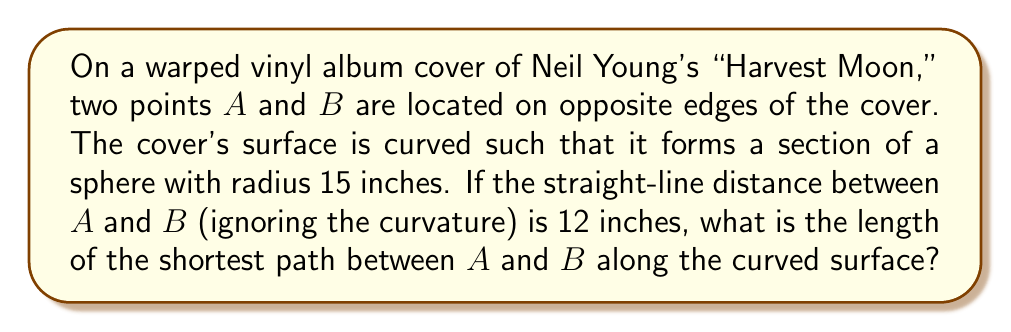Solve this math problem. To solve this problem, we need to use concepts from spherical geometry:

1) First, we need to find the central angle $\theta$ between the two points. We can do this using the formula for the chord length of a circle:

   $$ d = 2R \sin(\frac{\theta}{2}) $$

   Where $d$ is the straight-line distance, $R$ is the radius of the sphere, and $\theta$ is the central angle in radians.

2) Rearranging this formula:

   $$ \frac{\theta}{2} = \arcsin(\frac{d}{2R}) $$

3) Substituting our values ($d = 12$ inches, $R = 15$ inches):

   $$ \frac{\theta}{2} = \arcsin(\frac{12}{2 * 15}) = \arcsin(0.4) $$

4) Solving this:

   $$ \frac{\theta}{2} \approx 0.4115 \text{ radians} $$
   $$ \theta \approx 0.8230 \text{ radians} $$

5) Now that we have the central angle, we can find the length of the arc. The arc length formula is:

   $$ s = R\theta $$

   Where $s$ is the arc length, $R$ is the radius, and $\theta$ is the central angle in radians.

6) Substituting our values:

   $$ s = 15 * 0.8230 \approx 12.345 \text{ inches} $$

Therefore, the shortest path between A and B along the curved surface is approximately 12.345 inches.
Answer: $12.345$ inches 